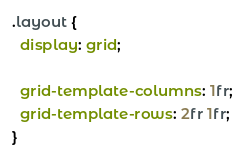Convert code to text. <code><loc_0><loc_0><loc_500><loc_500><_CSS_>.layout {
  display: grid;

  grid-template-columns: 1fr;
  grid-template-rows: 2fr 1fr;
}
</code> 